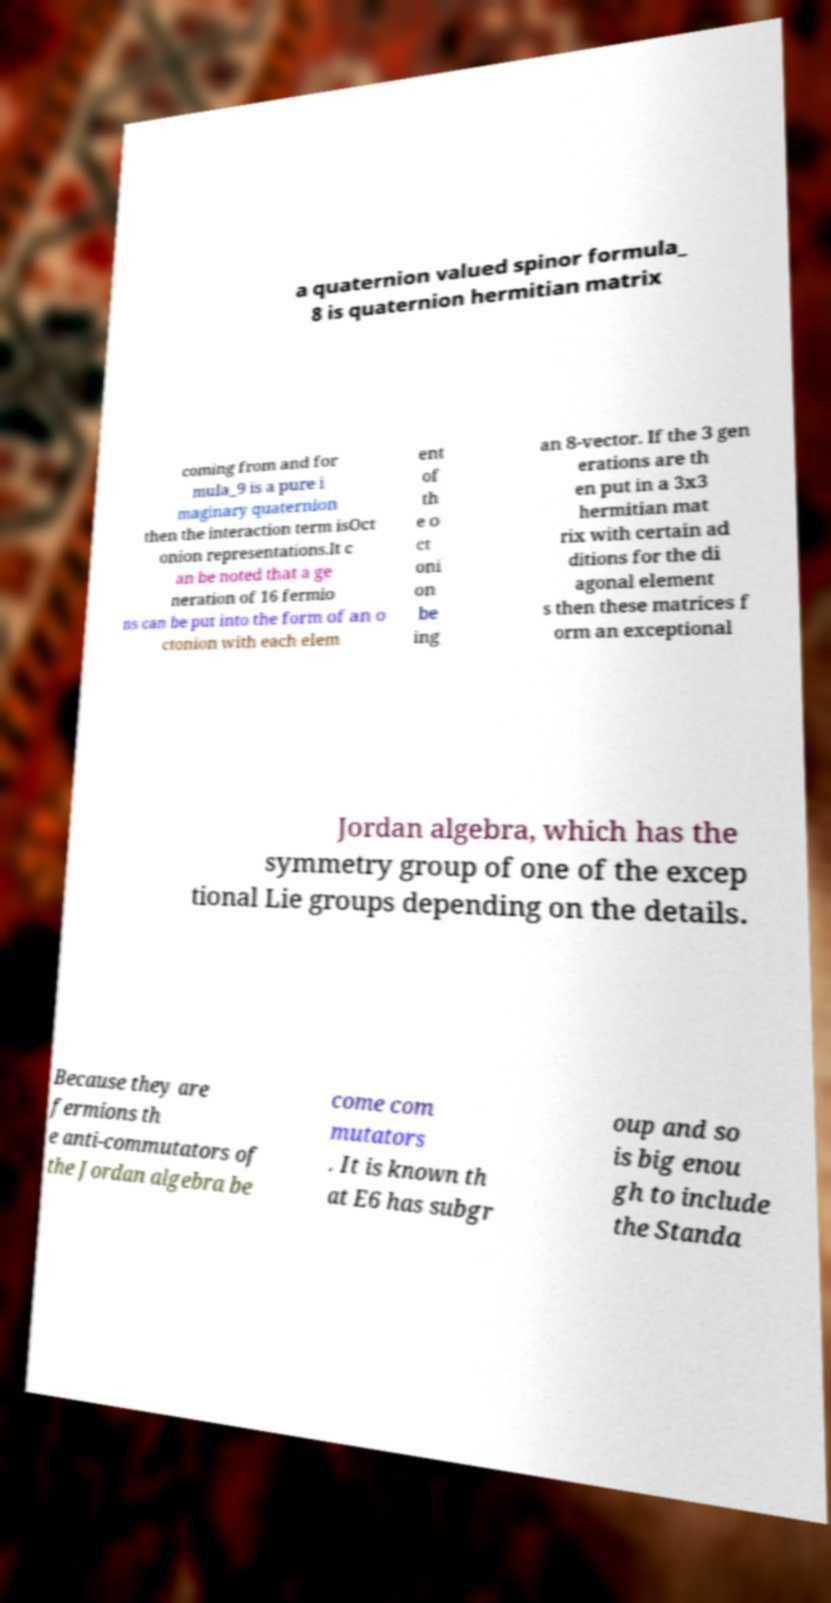There's text embedded in this image that I need extracted. Can you transcribe it verbatim? a quaternion valued spinor formula_ 8 is quaternion hermitian matrix coming from and for mula_9 is a pure i maginary quaternion then the interaction term isOct onion representations.It c an be noted that a ge neration of 16 fermio ns can be put into the form of an o ctonion with each elem ent of th e o ct oni on be ing an 8-vector. If the 3 gen erations are th en put in a 3x3 hermitian mat rix with certain ad ditions for the di agonal element s then these matrices f orm an exceptional Jordan algebra, which has the symmetry group of one of the excep tional Lie groups depending on the details. Because they are fermions th e anti-commutators of the Jordan algebra be come com mutators . It is known th at E6 has subgr oup and so is big enou gh to include the Standa 